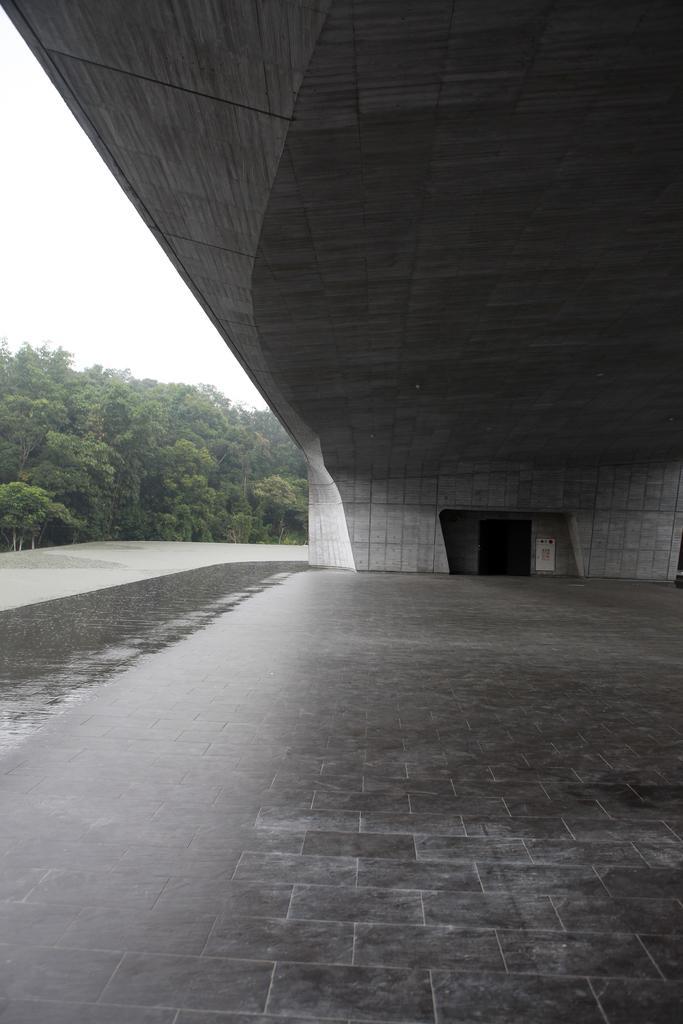In one or two sentences, can you explain what this image depicts? I think in this picture, there is bridge with a door. At the bottom, there are tiles. Towards the left, there are trees and sky. 